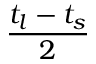Convert formula to latex. <formula><loc_0><loc_0><loc_500><loc_500>\frac { t _ { l } - t _ { s } } { 2 }</formula> 